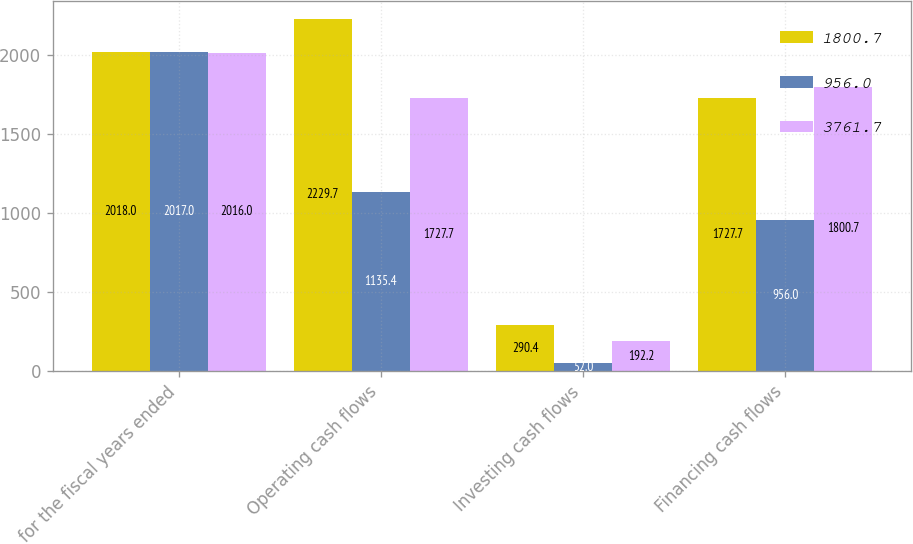<chart> <loc_0><loc_0><loc_500><loc_500><stacked_bar_chart><ecel><fcel>for the fiscal years ended<fcel>Operating cash flows<fcel>Investing cash flows<fcel>Financing cash flows<nl><fcel>1800.7<fcel>2018<fcel>2229.7<fcel>290.4<fcel>1727.7<nl><fcel>956<fcel>2017<fcel>1135.4<fcel>52<fcel>956<nl><fcel>3761.7<fcel>2016<fcel>1727.7<fcel>192.2<fcel>1800.7<nl></chart> 